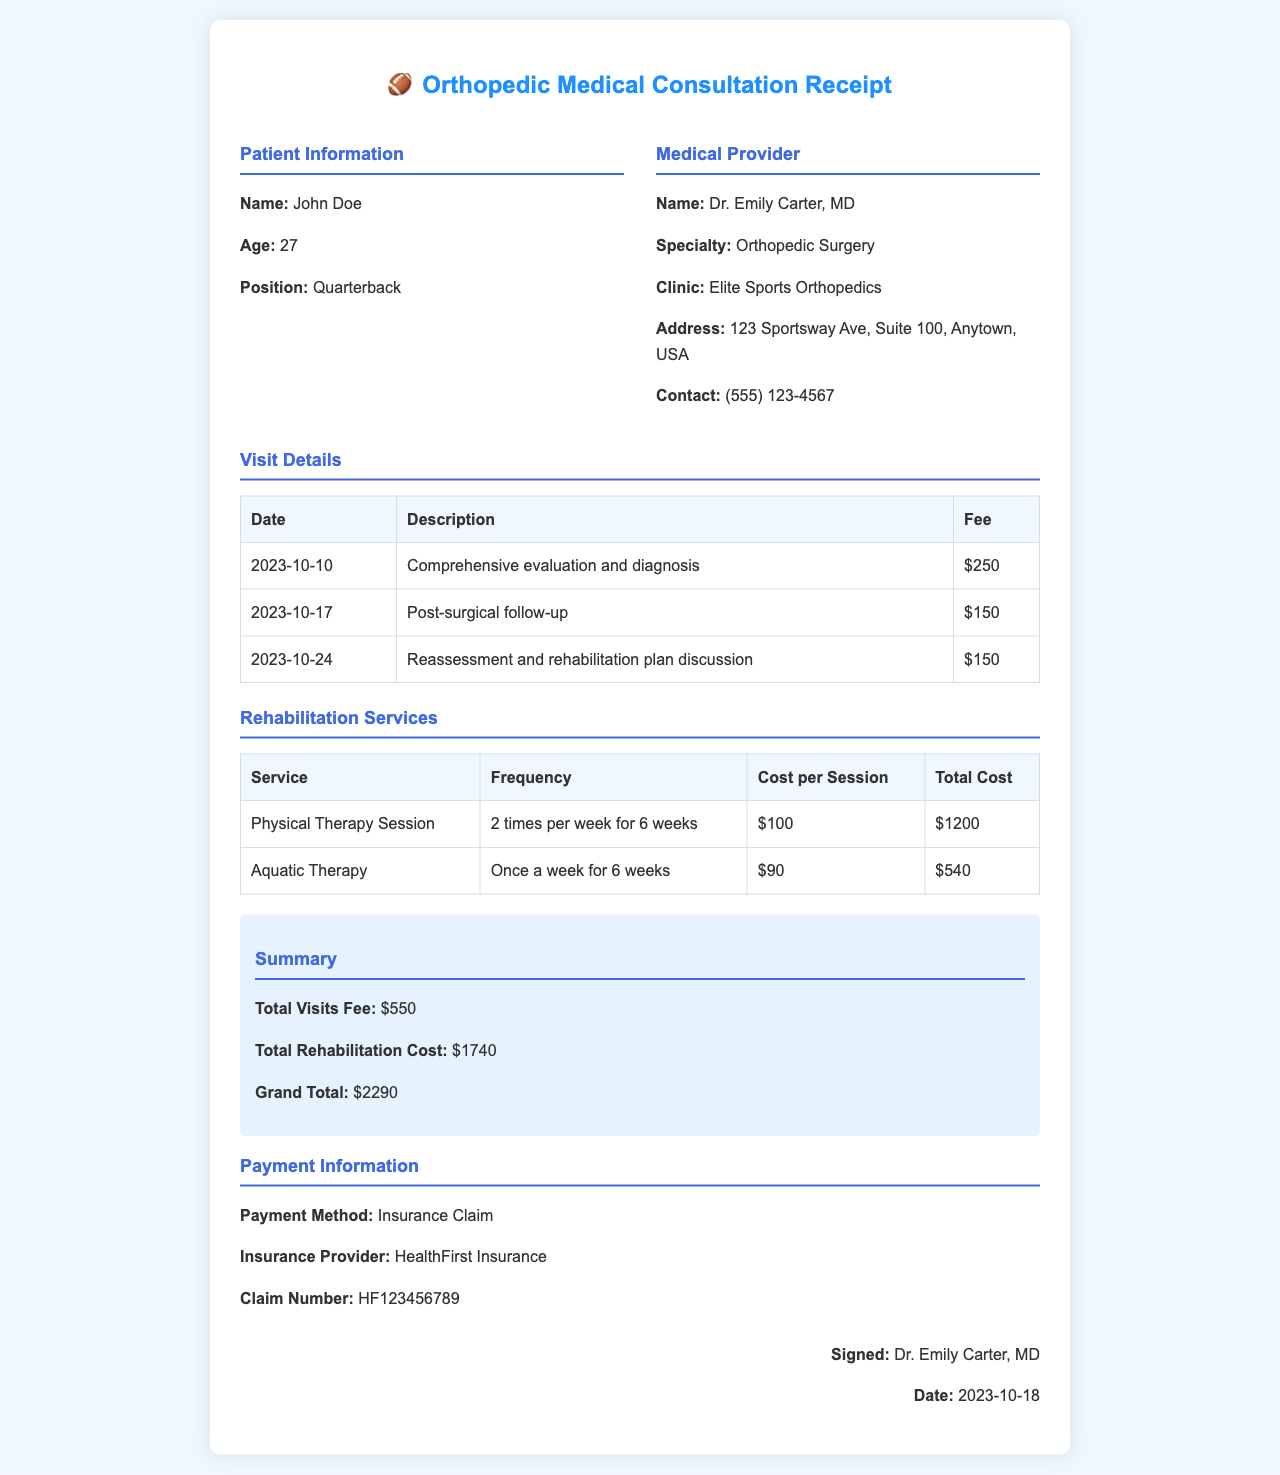what is the patient's name? The patient's name is listed in the document under the Patient Information section as John Doe.
Answer: John Doe what is the date of the comprehensive evaluation? The date of the comprehensive evaluation is noted in the Visit Details table as 2023-10-10.
Answer: 2023-10-10 what is the cost of the physical therapy session? The cost of the physical therapy session is detailed in the Rehabilitation Services table as $100 per session.
Answer: $100 how many visits were there in total? The number of visits can be found by counting the entries in the Visit Details table, which shows three visits.
Answer: 3 what is the total rehabilitation cost? The total rehabilitation cost is the sum of all rehabilitation service costs presented in the Rehabilitation Services table, which is $1200 + $540.
Answer: $1740 who is the medical provider? The medical provider's name is clearly mentioned in the document in the Medical Provider section as Dr. Emily Carter, MD.
Answer: Dr. Emily Carter, MD what is the grand total of the consultation? The grand total can be found in the Summary section, which summarizes all costs, showing $2290 as the grand total.
Answer: $2290 what is the insurance provider's name? The insurance provider can be found in the Payment Information section as HealthFirst Insurance.
Answer: HealthFirst Insurance what is the frequency of aquatic therapy sessions? The frequency of aquatic therapy sessions is indicated in the Rehabilitation Services table as once a week for 6 weeks.
Answer: Once a week for 6 weeks 